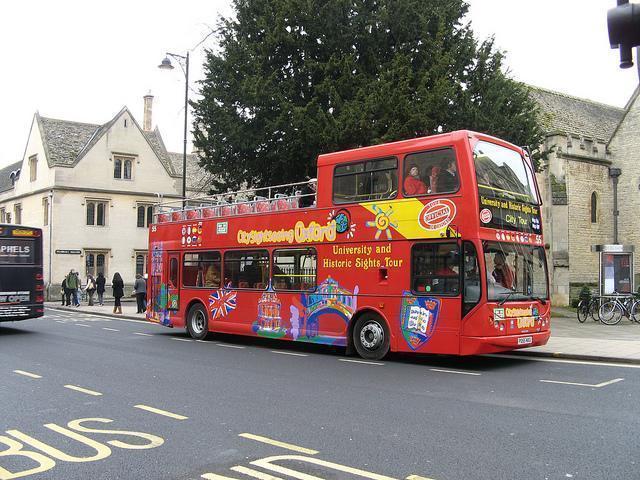Who are the passengers inside the red bus?
Choose the right answer and clarify with the format: 'Answer: answer
Rationale: rationale.'
Options: Actresses, tourists, medical workers, politicians. Answer: tourists.
Rationale: The bust logo states it is a historic sights tour. 